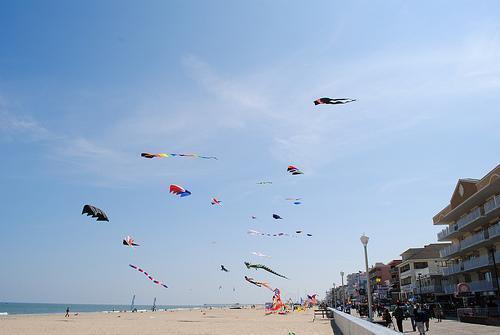How many distinguishable faces are visible?
Give a very brief answer. 0. 